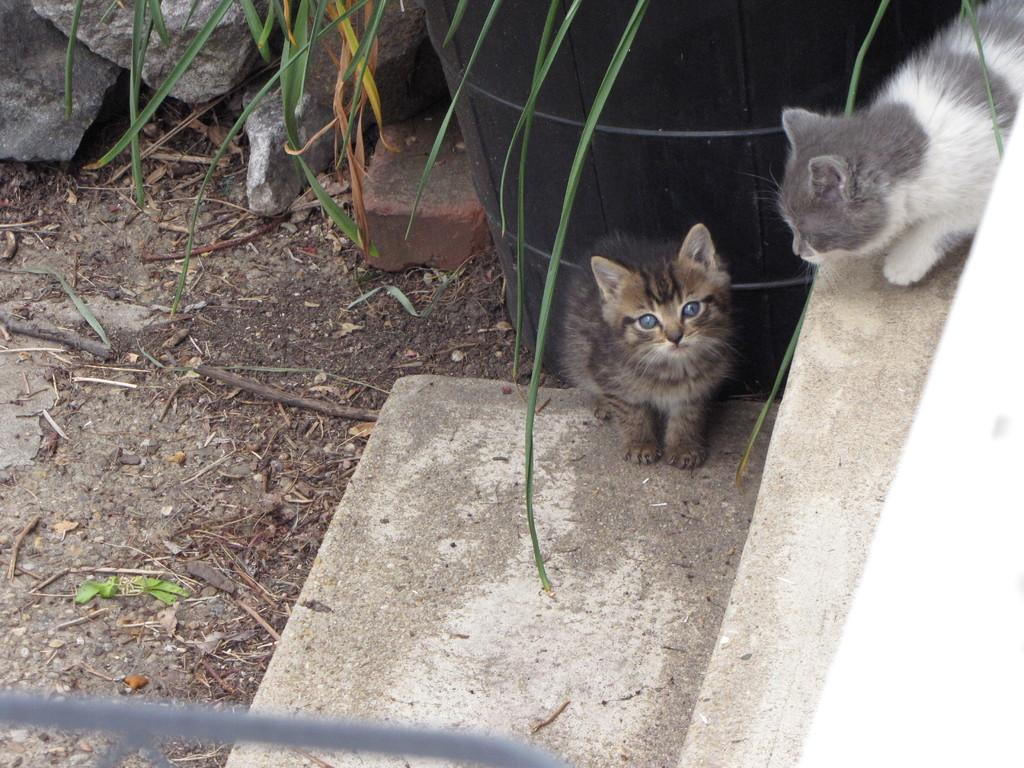How many cats are in the image? There are two cats in the image. What are the cats doing in the image? The cats are standing on steps. What can be seen in the background of the image? There is a black color object and rocks in the background. Are there any other objects visible in the background? Yes, there are other objects in the background. What type of screw can be seen holding the cats together in the image? There is no screw present in the image, and the cats are not physically connected. 